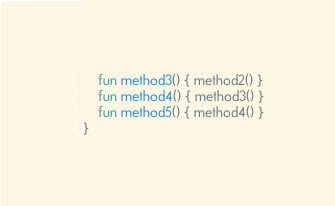<code> <loc_0><loc_0><loc_500><loc_500><_Kotlin_>    fun method3() { method2() }
    fun method4() { method3() }
    fun method5() { method4() }
}
</code> 